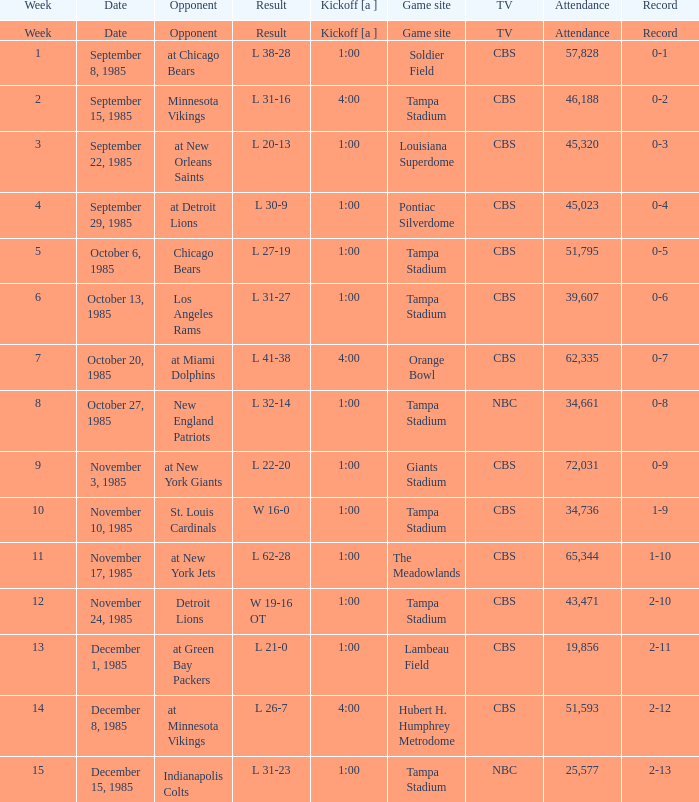When did the game against the st. louis cardinals broadcasted on cbs begin? 1:00. 